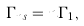<formula> <loc_0><loc_0><loc_500><loc_500>\Gamma _ { n s } = n \Gamma _ { 1 } ,</formula> 